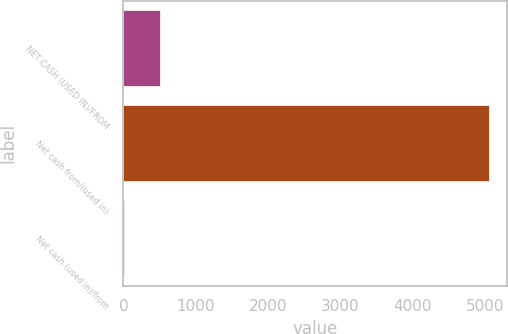<chart> <loc_0><loc_0><loc_500><loc_500><bar_chart><fcel>NET CASH (USED IN)/FROM<fcel>Net cash from/(used in)<fcel>Net cash (used in)/from<nl><fcel>507.2<fcel>5054<fcel>2<nl></chart> 